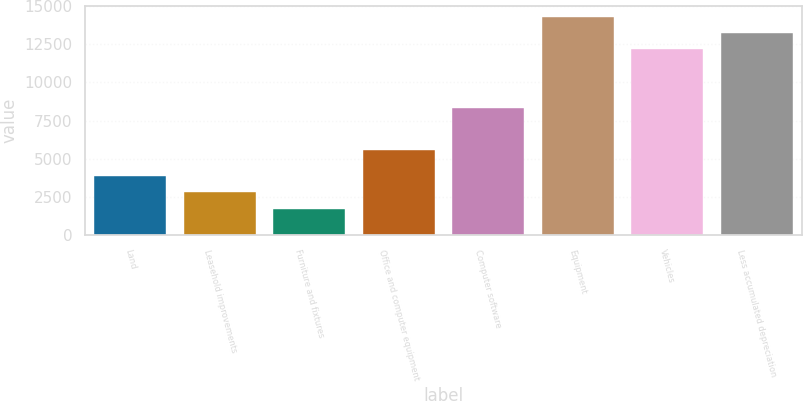Convert chart to OTSL. <chart><loc_0><loc_0><loc_500><loc_500><bar_chart><fcel>Land<fcel>Leasehold improvements<fcel>Furniture and fixtures<fcel>Office and computer equipment<fcel>Computer software<fcel>Equipment<fcel>Vehicles<fcel>Less accumulated depreciation<nl><fcel>3877<fcel>2814.5<fcel>1752<fcel>5585<fcel>8313<fcel>14295<fcel>12170<fcel>13232.5<nl></chart> 